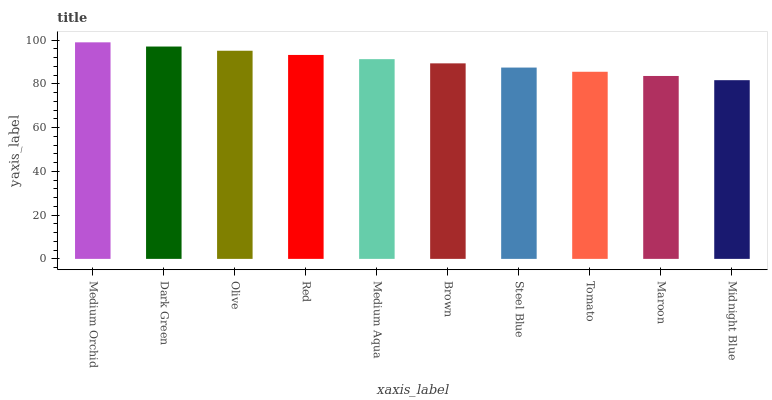Is Midnight Blue the minimum?
Answer yes or no. Yes. Is Medium Orchid the maximum?
Answer yes or no. Yes. Is Dark Green the minimum?
Answer yes or no. No. Is Dark Green the maximum?
Answer yes or no. No. Is Medium Orchid greater than Dark Green?
Answer yes or no. Yes. Is Dark Green less than Medium Orchid?
Answer yes or no. Yes. Is Dark Green greater than Medium Orchid?
Answer yes or no. No. Is Medium Orchid less than Dark Green?
Answer yes or no. No. Is Medium Aqua the high median?
Answer yes or no. Yes. Is Brown the low median?
Answer yes or no. Yes. Is Olive the high median?
Answer yes or no. No. Is Olive the low median?
Answer yes or no. No. 